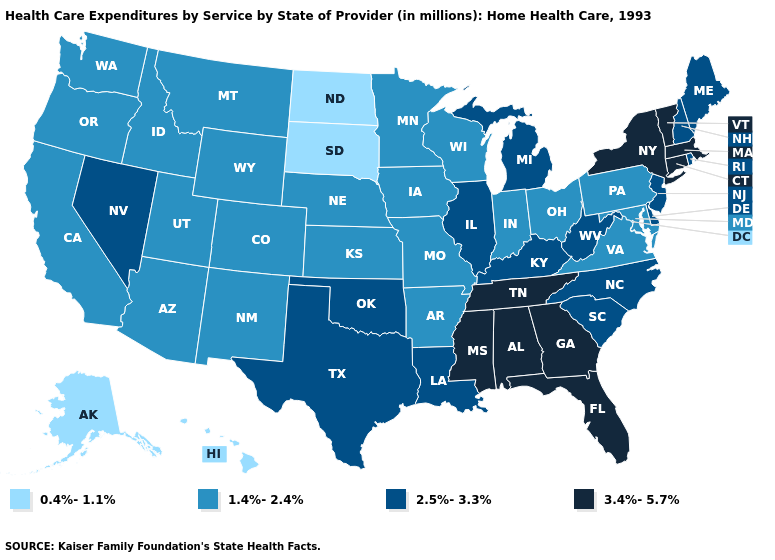Is the legend a continuous bar?
Give a very brief answer. No. What is the value of South Dakota?
Write a very short answer. 0.4%-1.1%. Does Oklahoma have the same value as North Carolina?
Short answer required. Yes. What is the highest value in the West ?
Concise answer only. 2.5%-3.3%. Name the states that have a value in the range 3.4%-5.7%?
Be succinct. Alabama, Connecticut, Florida, Georgia, Massachusetts, Mississippi, New York, Tennessee, Vermont. Does Illinois have a higher value than Maine?
Short answer required. No. What is the value of Illinois?
Answer briefly. 2.5%-3.3%. Among the states that border Maryland , does Pennsylvania have the highest value?
Be succinct. No. Among the states that border Oklahoma , which have the highest value?
Give a very brief answer. Texas. Which states hav the highest value in the Northeast?
Quick response, please. Connecticut, Massachusetts, New York, Vermont. What is the value of Missouri?
Quick response, please. 1.4%-2.4%. Name the states that have a value in the range 3.4%-5.7%?
Be succinct. Alabama, Connecticut, Florida, Georgia, Massachusetts, Mississippi, New York, Tennessee, Vermont. What is the value of North Carolina?
Concise answer only. 2.5%-3.3%. Which states have the highest value in the USA?
Concise answer only. Alabama, Connecticut, Florida, Georgia, Massachusetts, Mississippi, New York, Tennessee, Vermont. Which states have the highest value in the USA?
Concise answer only. Alabama, Connecticut, Florida, Georgia, Massachusetts, Mississippi, New York, Tennessee, Vermont. 